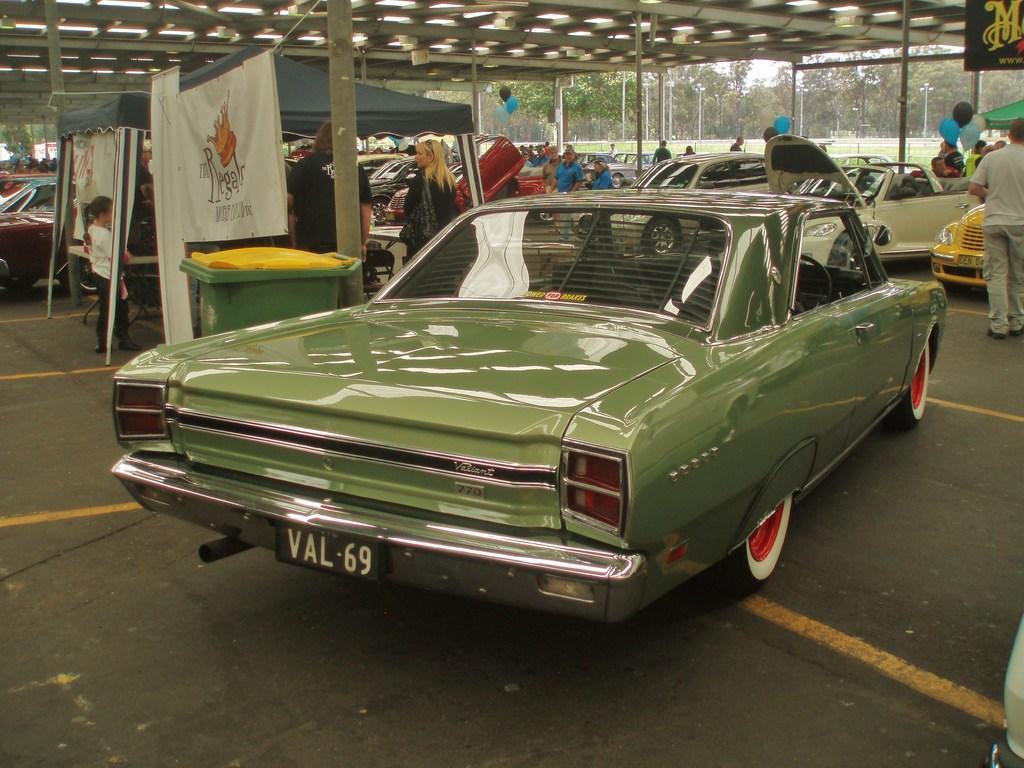Can you describe this image briefly? In this picture there are cars, people, tents, dustbin and banners. At the top it is ceiling. In the background there are trees and fencing. 